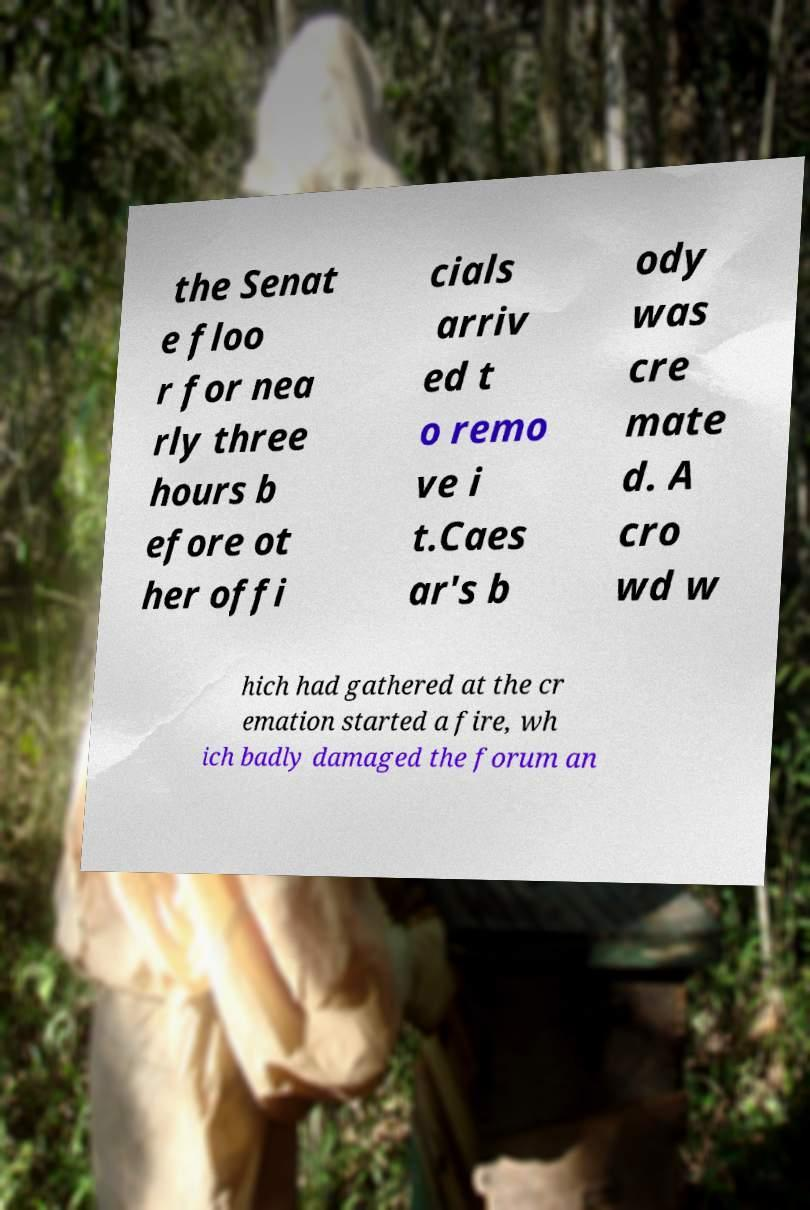There's text embedded in this image that I need extracted. Can you transcribe it verbatim? the Senat e floo r for nea rly three hours b efore ot her offi cials arriv ed t o remo ve i t.Caes ar's b ody was cre mate d. A cro wd w hich had gathered at the cr emation started a fire, wh ich badly damaged the forum an 